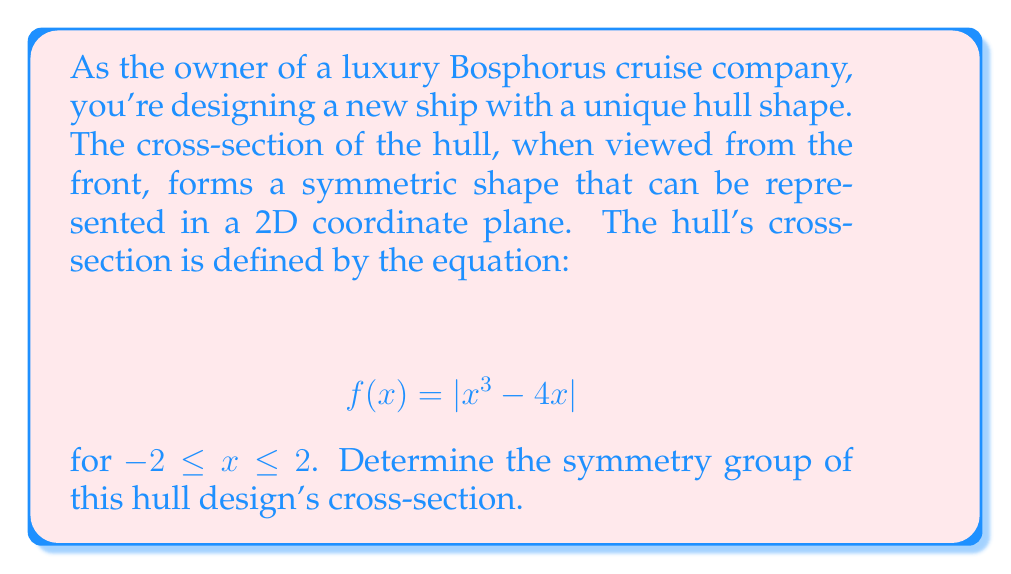Can you solve this math problem? To determine the symmetry group of the hull's cross-section, we need to identify all the symmetries of the given function $f(x) = |x^3 - 4x|$ in the interval $[-2, 2]$. Let's approach this step-by-step:

1) First, let's consider the possible symmetries:
   a) Reflection about the y-axis
   b) Reflection about the x-axis
   c) Rotation by 180 degrees about the origin
   d) Identity transformation

2) To check for y-axis symmetry, we need to verify if $f(-x) = f(x)$:
   $f(-x) = |(-x)^3 - 4(-x)| = |-x^3 + 4x| = |-(x^3 - 4x)| = |x^3 - 4x| = f(x)$
   This equality holds, so the function is symmetric about the y-axis.

3) To check for x-axis symmetry, we need to verify if $f(x) = -f(x)$:
   This is clearly not true for all x in the given interval, so there's no x-axis symmetry.

4) Rotation by 180 degrees is equivalent to the composition of reflections about both axes. Since we only have y-axis symmetry, this rotation symmetry doesn't exist.

5) The identity transformation always exists for any function.

Therefore, the symmetry group consists of two elements: the identity transformation and reflection about the y-axis.

This group is isomorphic to the cyclic group of order 2, $C_2$, or equivalently, to the multiplicative group $\{1, -1\}$ under multiplication.

The group table for this symmetry group is:

$$
\begin{array}{c|cc}
   & e & r \\
\hline
e & e & r \\
r & r & e
\end{array}
$$

where $e$ represents the identity transformation and $r$ represents reflection about the y-axis.
Answer: The symmetry group of the hull design's cross-section is $C_2$, the cyclic group of order 2. 